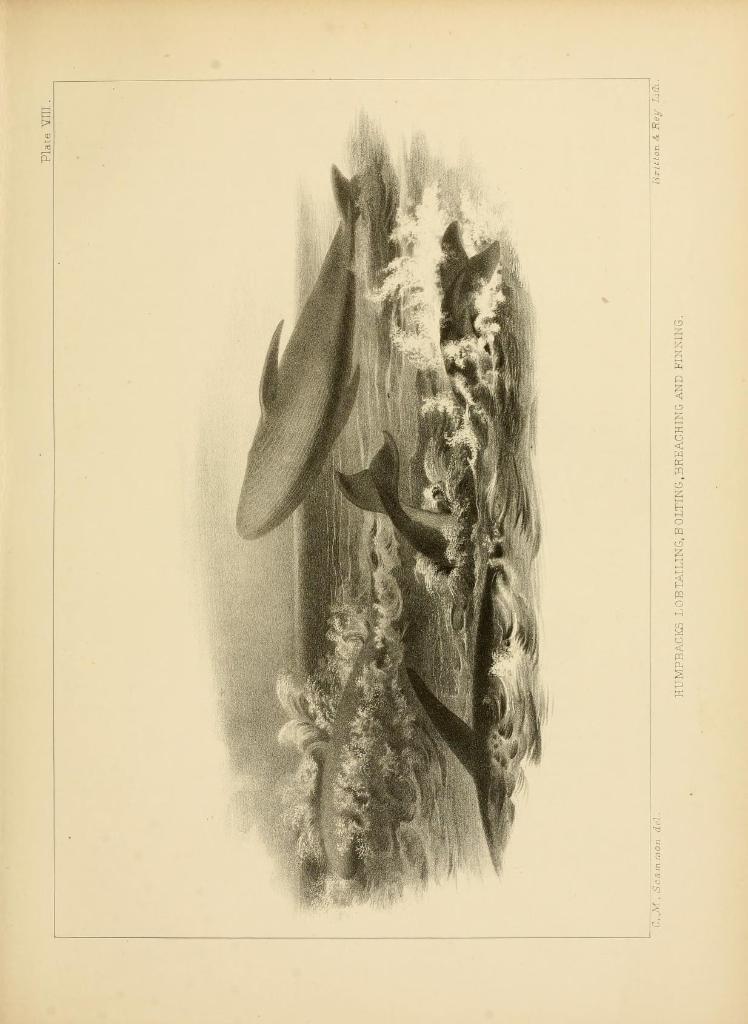Could you give a brief overview of what you see in this image? In this picture we can see the sketch of fishes and water on the paper and on the paper it is written something. 